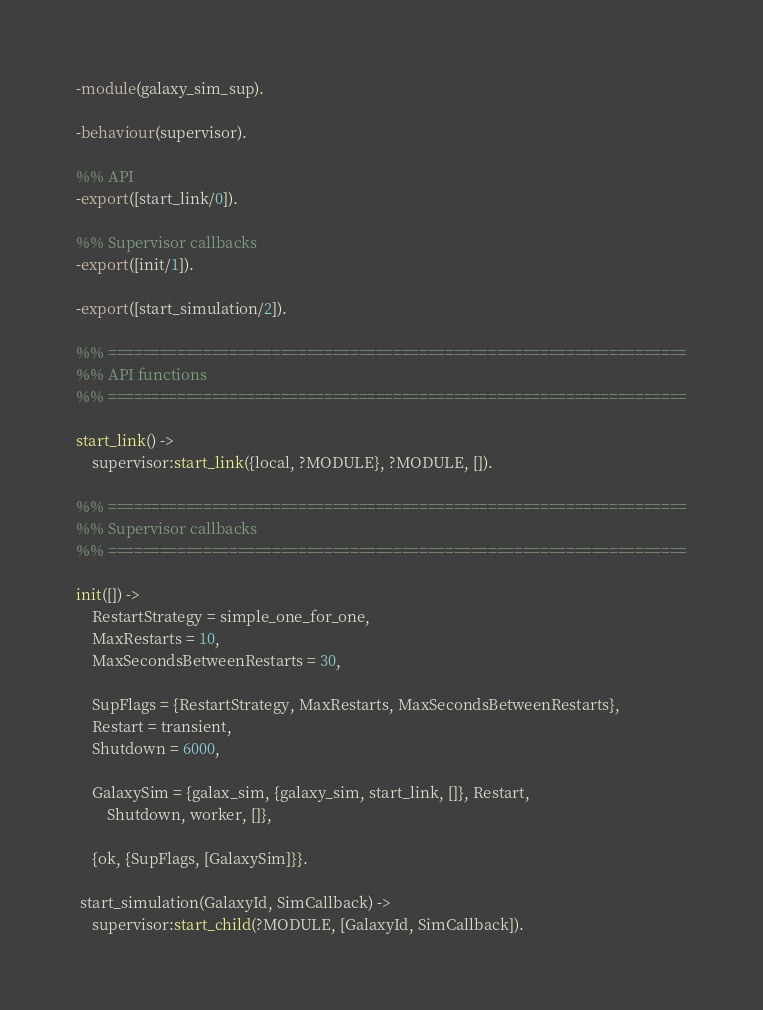<code> <loc_0><loc_0><loc_500><loc_500><_Erlang_>-module(galaxy_sim_sup).

-behaviour(supervisor).

%% API
-export([start_link/0]).

%% Supervisor callbacks
-export([init/1]).

-export([start_simulation/2]).

%% ===================================================================
%% API functions
%% ===================================================================

start_link() ->
    supervisor:start_link({local, ?MODULE}, ?MODULE, []).

%% ===================================================================
%% Supervisor callbacks
%% ===================================================================

init([]) ->
    RestartStrategy = simple_one_for_one,
    MaxRestarts = 10, 
    MaxSecondsBetweenRestarts = 30, 

    SupFlags = {RestartStrategy, MaxRestarts, MaxSecondsBetweenRestarts},
    Restart = transient,
    Shutdown = 6000,

    GalaxySim = {galax_sim, {galaxy_sim, start_link, []}, Restart, 
        Shutdown, worker, []},

    {ok, {SupFlags, [GalaxySim]}}.

 start_simulation(GalaxyId, SimCallback) ->
    supervisor:start_child(?MODULE, [GalaxyId, SimCallback]).
</code> 